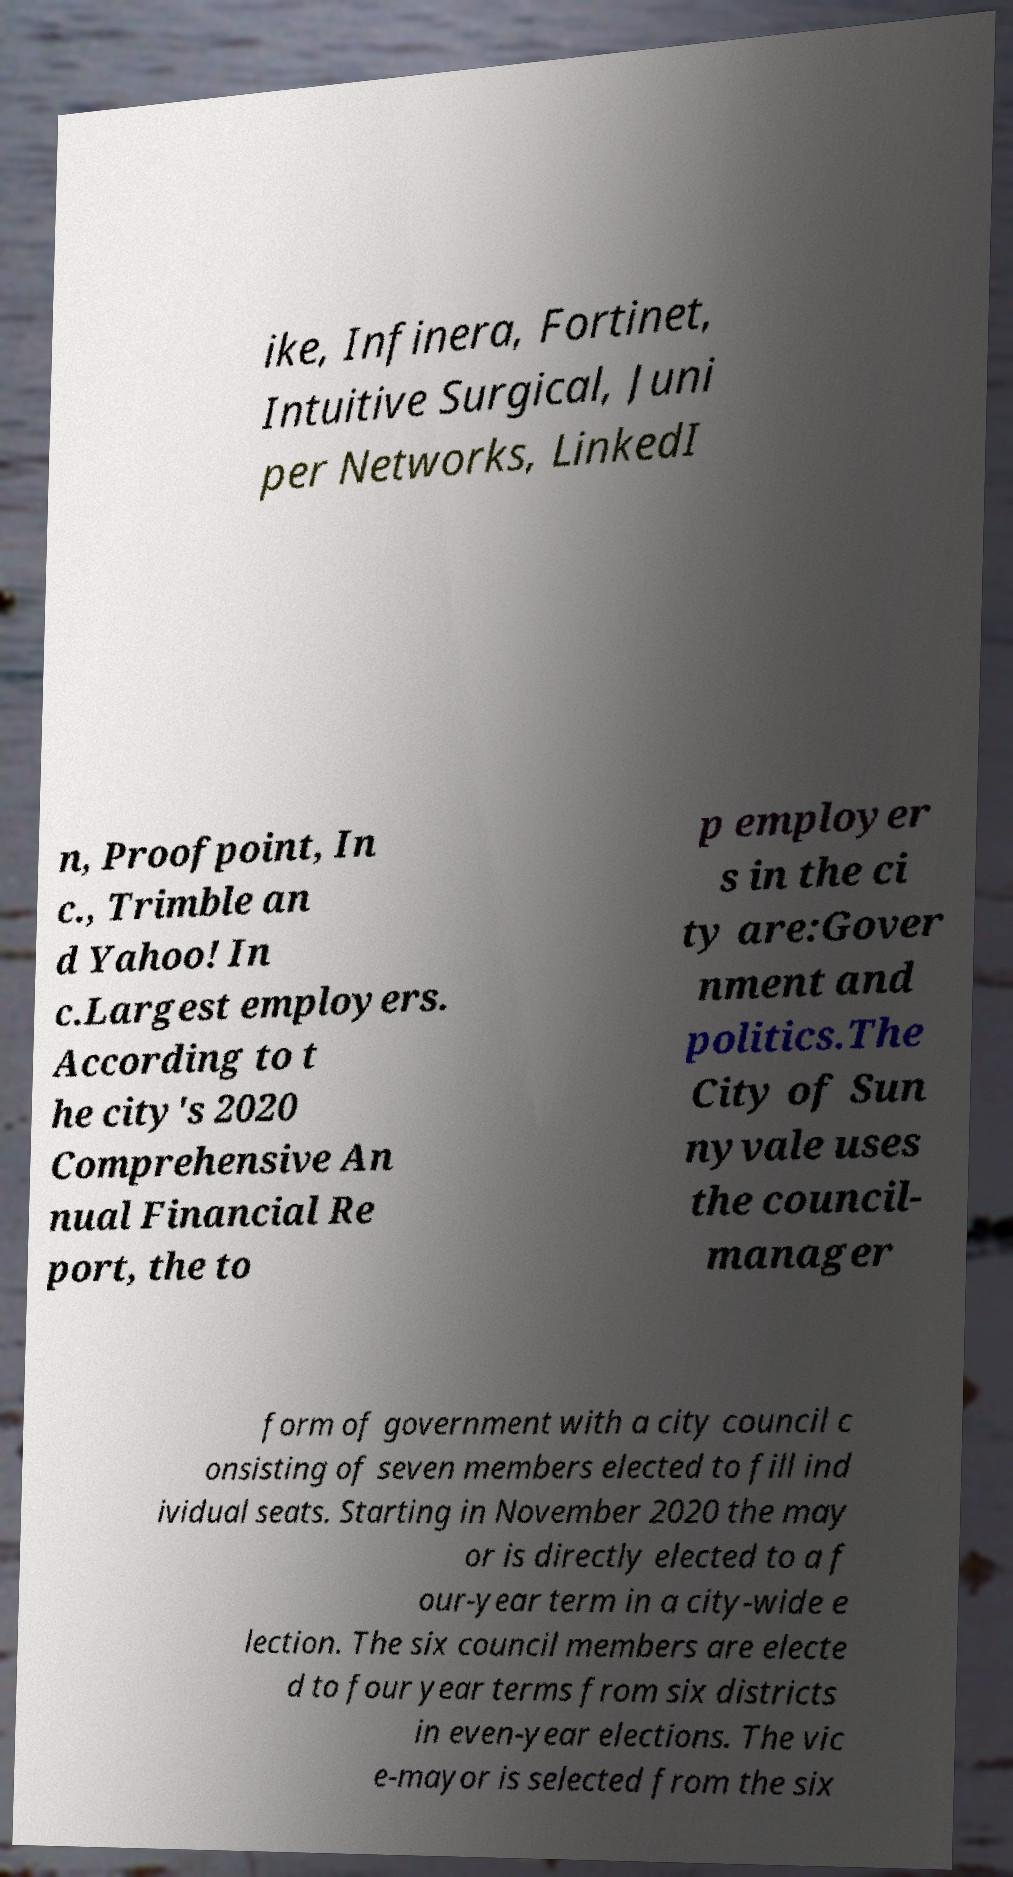Could you assist in decoding the text presented in this image and type it out clearly? ike, Infinera, Fortinet, Intuitive Surgical, Juni per Networks, LinkedI n, Proofpoint, In c., Trimble an d Yahoo! In c.Largest employers. According to t he city's 2020 Comprehensive An nual Financial Re port, the to p employer s in the ci ty are:Gover nment and politics.The City of Sun nyvale uses the council- manager form of government with a city council c onsisting of seven members elected to fill ind ividual seats. Starting in November 2020 the may or is directly elected to a f our-year term in a city-wide e lection. The six council members are electe d to four year terms from six districts in even-year elections. The vic e-mayor is selected from the six 